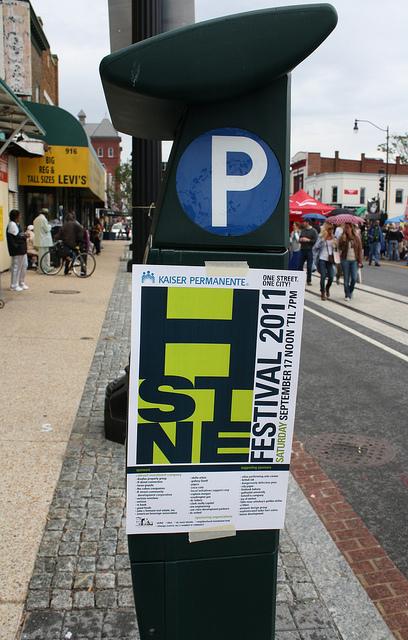What city is this?
Give a very brief answer. New york. Is there a bike on the sidewalk?
Short answer required. Yes. Who is sponsoring the festival?
Be succinct. Kaiser permanente. What letter is in the blue circle?
Give a very brief answer. P. 